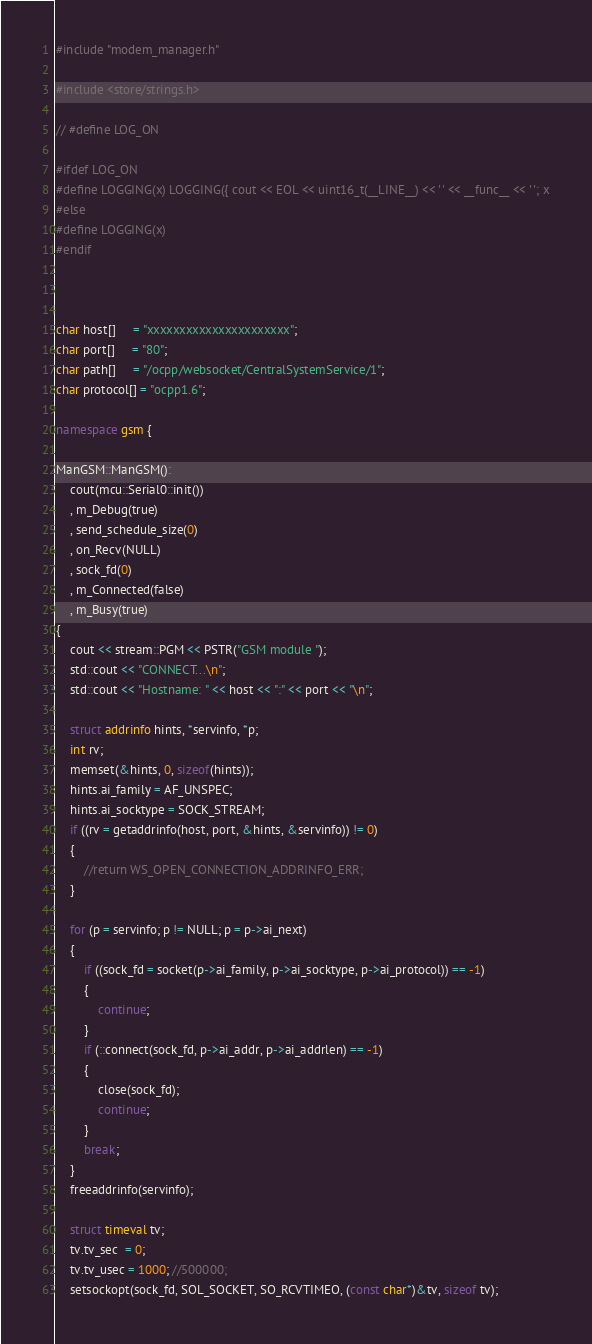Convert code to text. <code><loc_0><loc_0><loc_500><loc_500><_C++_>#include "modem_manager.h"

#include <store/strings.h>

// #define LOG_ON

#ifdef LOG_ON
#define LOGGING(x) LOGGING({ cout << EOL << uint16_t(__LINE__) << ' ' << __func__ << ' '; x
#else
#define LOGGING(x)
#endif



char host[]     = "xxxxxxxxxxxxxxxxxxxxxx";
char port[]     = "80";
char path[]     = "/ocpp/websocket/CentralSystemService/1";
char protocol[] = "ocpp1.6";

namespace gsm {

ManGSM::ManGSM():
    cout(mcu::Serial0::init())
    , m_Debug(true)
    , send_schedule_size(0)
    , on_Recv(NULL)
    , sock_fd(0)
    , m_Connected(false)
    , m_Busy(true)
{
    cout << stream::PGM << PSTR("GSM module ");
    std::cout << "CONNECT...\n";
    std::cout << "Hostname: " << host << ":" << port << "\n";
    
    struct addrinfo hints, *servinfo, *p;
    int rv;
    memset(&hints, 0, sizeof(hints));
    hints.ai_family = AF_UNSPEC;
    hints.ai_socktype = SOCK_STREAM;
    if ((rv = getaddrinfo(host, port, &hints, &servinfo)) != 0)
    {
        //return WS_OPEN_CONNECTION_ADDRINFO_ERR;
    }
    
    for (p = servinfo; p != NULL; p = p->ai_next)
    {
        if ((sock_fd = socket(p->ai_family, p->ai_socktype, p->ai_protocol)) == -1)
        {
            continue;
        }
        if (::connect(sock_fd, p->ai_addr, p->ai_addrlen) == -1)
        {
            close(sock_fd);
            continue;
        }
        break;
    }
    freeaddrinfo(servinfo);
    
    struct timeval tv;
    tv.tv_sec  = 0;
    tv.tv_usec = 1000; //500000;
    setsockopt(sock_fd, SOL_SOCKET, SO_RCVTIMEO, (const char*)&tv, sizeof tv);</code> 